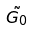Convert formula to latex. <formula><loc_0><loc_0><loc_500><loc_500>\tilde { G _ { 0 } }</formula> 